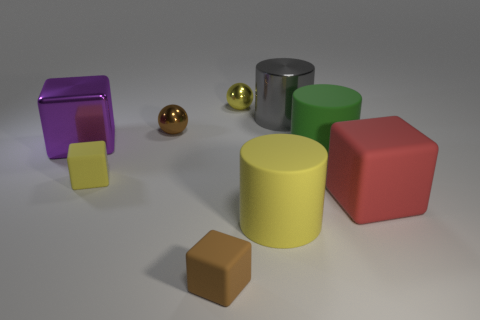There is a rubber block right of the green matte thing; does it have the same color as the object to the left of the tiny yellow matte cube?
Provide a succinct answer. No. Is the number of things that are to the right of the brown metal sphere less than the number of big green cylinders in front of the big red matte thing?
Ensure brevity in your answer.  No. What shape is the tiny object in front of the large red rubber cube?
Keep it short and to the point. Cube. How many other objects are the same material as the big red block?
Give a very brief answer. 4. Does the large yellow object have the same shape as the tiny yellow thing on the left side of the small brown rubber block?
Provide a short and direct response. No. There is a tiny brown object that is the same material as the yellow sphere; what is its shape?
Your answer should be very brief. Sphere. Are there more green objects behind the purple object than small yellow matte objects behind the brown metal object?
Make the answer very short. No. How many objects are either gray metallic objects or blue things?
Ensure brevity in your answer.  1. How many other things are the same color as the big metal cube?
Your answer should be compact. 0. What is the shape of the shiny thing that is the same size as the yellow ball?
Provide a succinct answer. Sphere. 